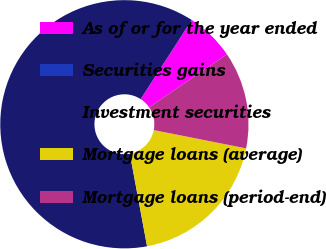<chart> <loc_0><loc_0><loc_500><loc_500><pie_chart><fcel>As of or for the year ended<fcel>Securities gains<fcel>Investment securities<fcel>Mortgage loans (average)<fcel>Mortgage loans (period-end)<nl><fcel>6.33%<fcel>0.01%<fcel>62.06%<fcel>18.96%<fcel>12.64%<nl></chart> 